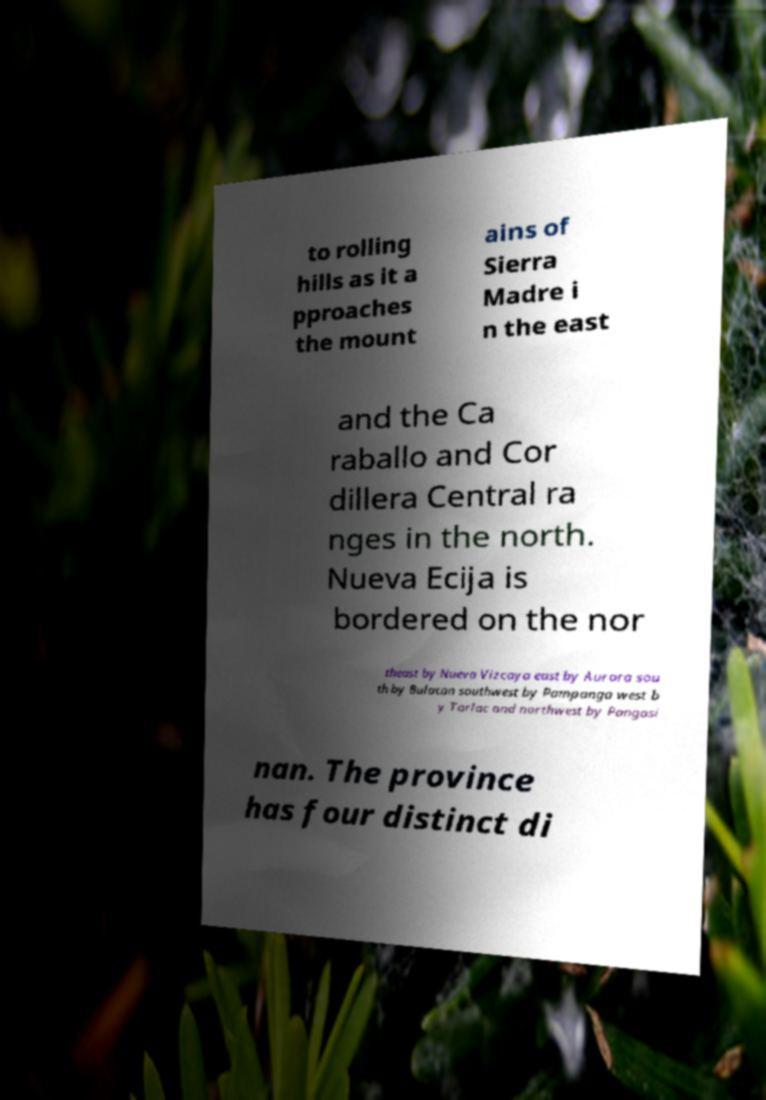Could you assist in decoding the text presented in this image and type it out clearly? to rolling hills as it a pproaches the mount ains of Sierra Madre i n the east and the Ca raballo and Cor dillera Central ra nges in the north. Nueva Ecija is bordered on the nor theast by Nueva Vizcaya east by Aurora sou th by Bulacan southwest by Pampanga west b y Tarlac and northwest by Pangasi nan. The province has four distinct di 